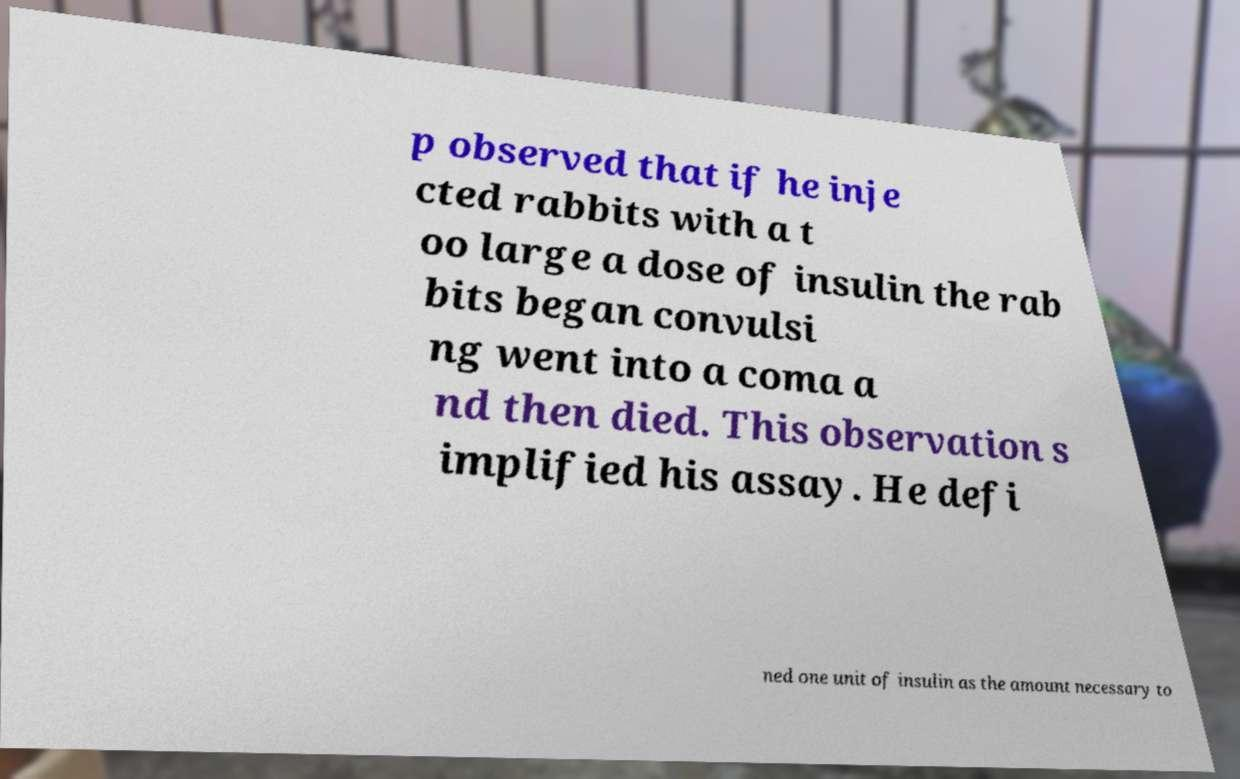What messages or text are displayed in this image? I need them in a readable, typed format. p observed that if he inje cted rabbits with a t oo large a dose of insulin the rab bits began convulsi ng went into a coma a nd then died. This observation s implified his assay. He defi ned one unit of insulin as the amount necessary to 